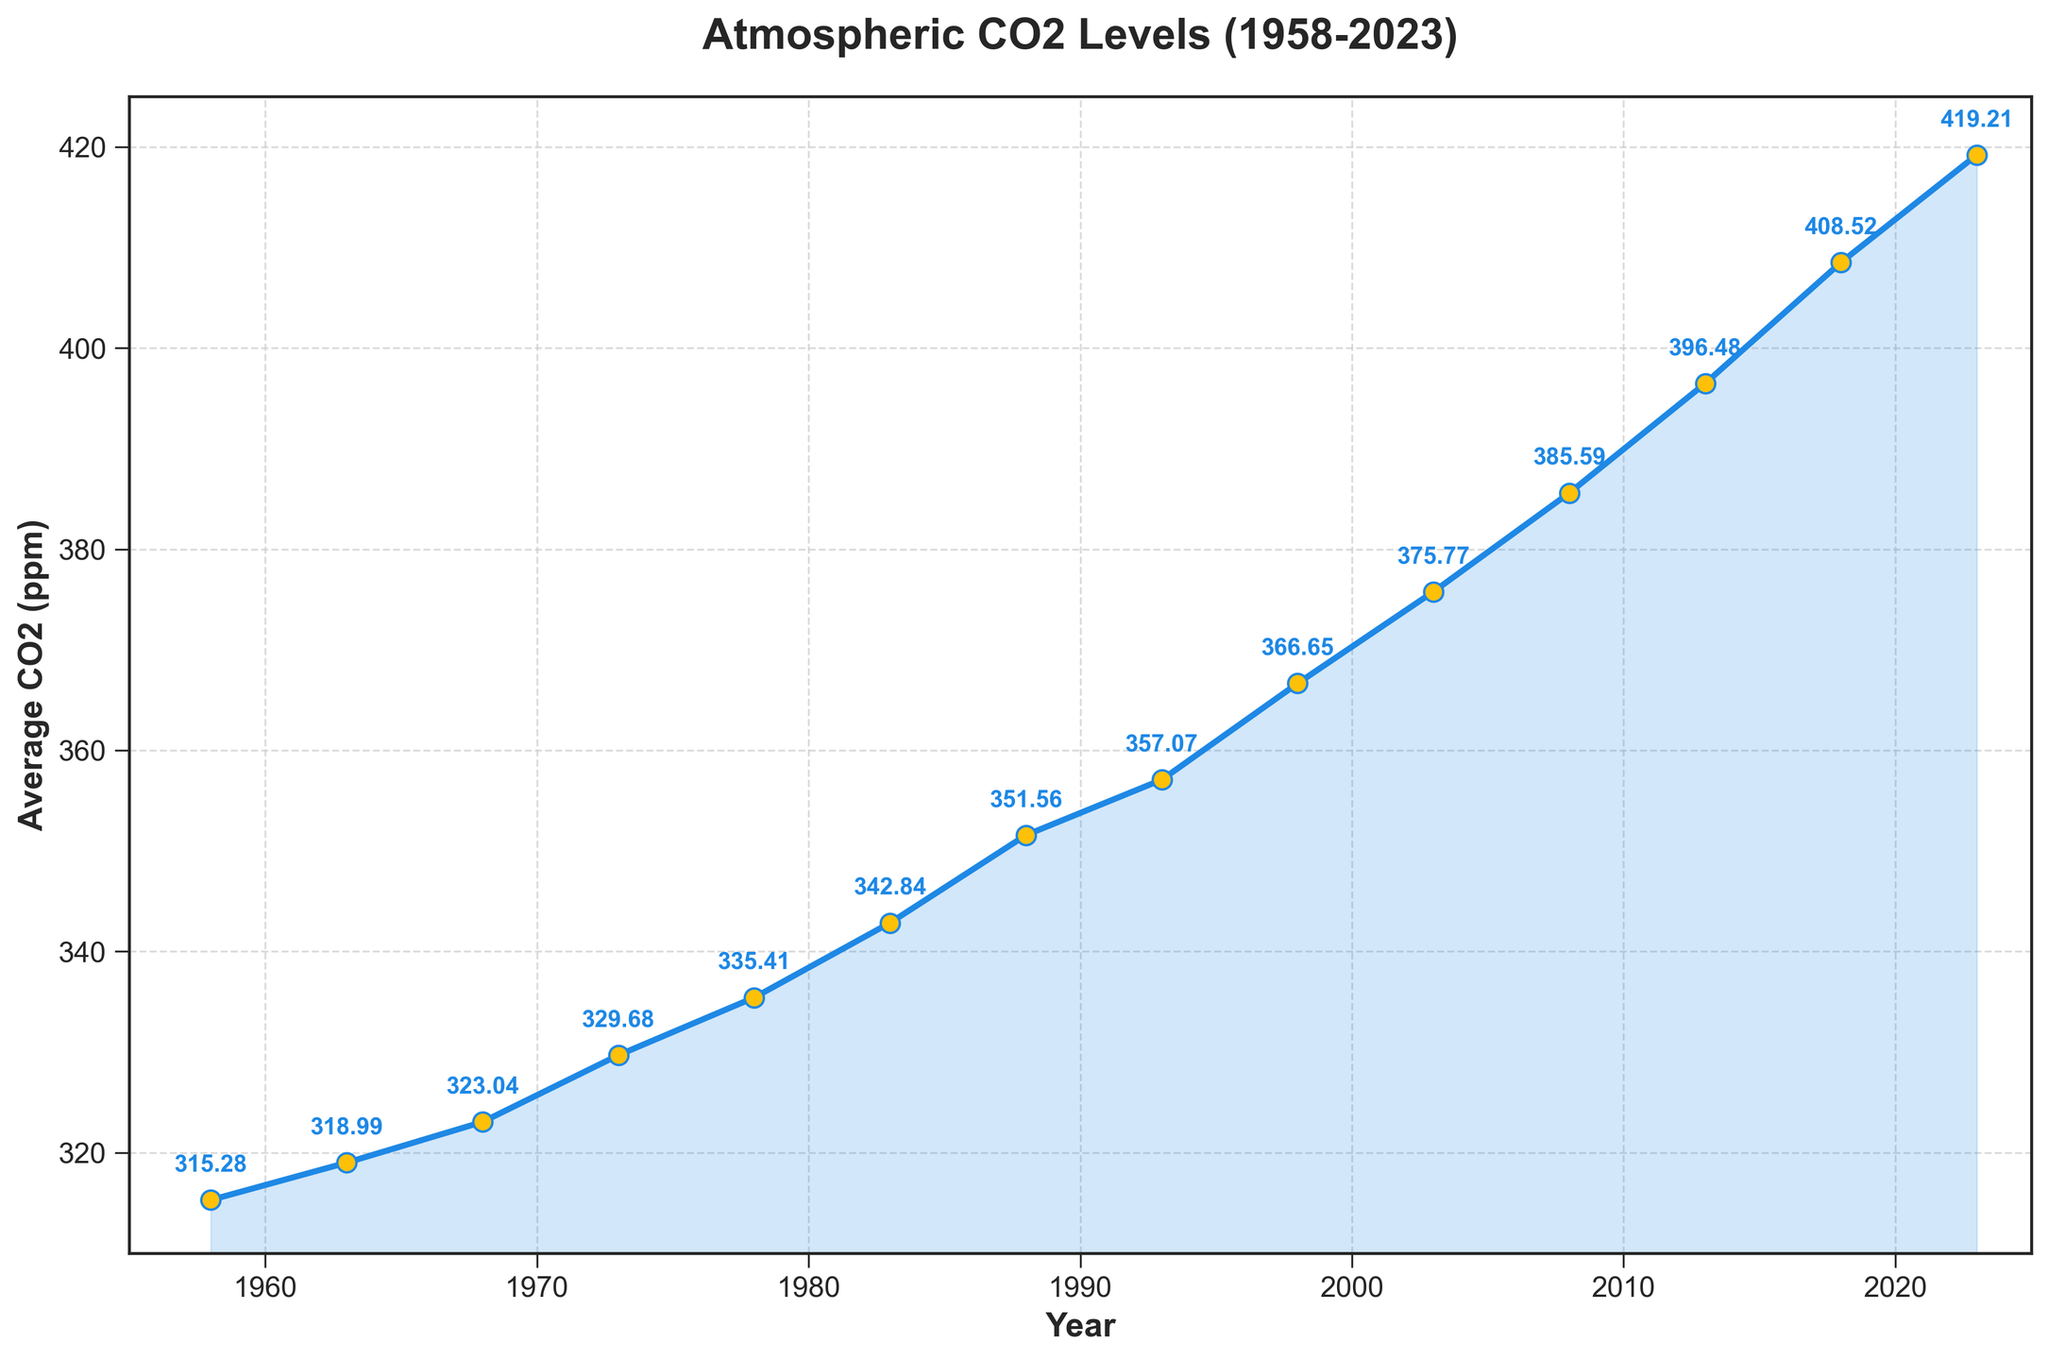What is the average CO2 level from 1958 to 2023? To calculate the average, sum the CO2 levels for each year and divide by the number of years. The CO2 levels are: 315.28 + 318.99 + 323.04 + 329.68 + 335.41 + 342.84 + 351.56 + 357.07 + 366.65 + 375.77 + 385.59 + 396.48 + 408.52 + 419.21. The sum is 4926.09, and there are 14 data points. Therefore, the average is 4926.09 / 14.
Answer: 351.86 ppm In which year did the CO2 level first exceed 370 ppm? Look at the plotted data points and find the first year where the CO2 level is above 370 ppm. This occurs in the year 1998 with a CO2 level of 366.65 ppm and finally in 2003 with 375.77 ppm exceeding 370 ppm.
Answer: 2003 By how much did the CO2 level increase from 1958 to 2023? Subtract the CO2 level of the earliest year (1958) from the latest year (2023) in the data. The CO2 level in 1958 is 315.28 ppm and in 2023 it is 419.21 ppm. The increase is 419.21 - 315.28.
Answer: 103.93 ppm Between which consecutive years was the largest increase in CO2 levels observed? Calculate the difference in CO2 levels between each pair of consecutive years and find the largest difference. The differences are: 318.99 - 315.28 = 3.71, 323.04 - 318.99 = 4.05, 329.68 - 323.04 = 6.64, 335.41 - 329.68 = 5.73, 342.84 - 335.41 = 7.43, 351.56 - 342.84 = 8.72, 357.07 - 351.56 = 5.51, 366.65 - 357.07 = 9.58, 375.77 - 366.65 = 9.12, 385.59 - 375.77 = 9.82, 396.48 - 385.59 = 10.89, 408.52 - 396.48 = 12.04, 419.21 - 408.52 = 10.69. The largest increase of 12.04 happens between 2013 and 2018.
Answer: Between 2013 and 2018 What is the highest CO2 level recorded in the given period? Identify the highest y-axis value from the plotted data points. The highest CO2 level recorded is 419.21 ppm in 2023.
Answer: 419.21 ppm How does the CO2 level in 1983 compare to that in 1978? Compare the y-values for the years 1983 and 1978. The CO2 levels are 342.84 ppm in 1983 and 335.41 ppm in 1978. The level in 1983 is higher by 342.84 - 335.41.
Answer: 7.43 ppm higher in 1983 What trend is observed in the atmospheric CO2 levels over the years? Examine the overall direction of the plotted line from 1958 to 2023. The line shows a consistent upward trend, indicating that atmospheric CO2 levels have been continuously rising over the years.
Answer: Increasing trend What is the difference in CO2 levels between 1963 and 2008? Subtract the CO2 level of 1963 from that of 2008. The CO2 level in 1963 is 318.99 ppm and in 2008 it is 385.59 ppm. The difference is 385.59 - 318.99.
Answer: 66.60 ppm By how much did the CO2 level increase on average per year between 1958 and 2023? Calculate the total increase in CO2 level from 1958 to 2023 and divide by the number of years. The total increase is 103.93 ppm and the number of years is 2023 - 1958 = 65 years. The average annual increase is 103.93 / 65.
Answer: 1.60 ppm per year 